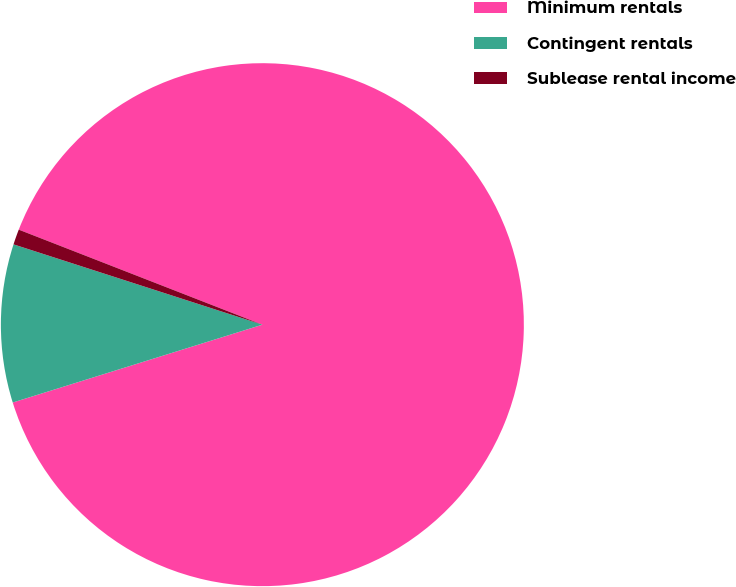Convert chart to OTSL. <chart><loc_0><loc_0><loc_500><loc_500><pie_chart><fcel>Minimum rentals<fcel>Contingent rentals<fcel>Sublease rental income<nl><fcel>89.27%<fcel>9.78%<fcel>0.95%<nl></chart> 